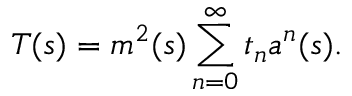<formula> <loc_0><loc_0><loc_500><loc_500>T ( s ) = m ^ { 2 } ( s ) \sum _ { n = 0 } ^ { \infty } t _ { n } a ^ { n } ( s ) .</formula> 